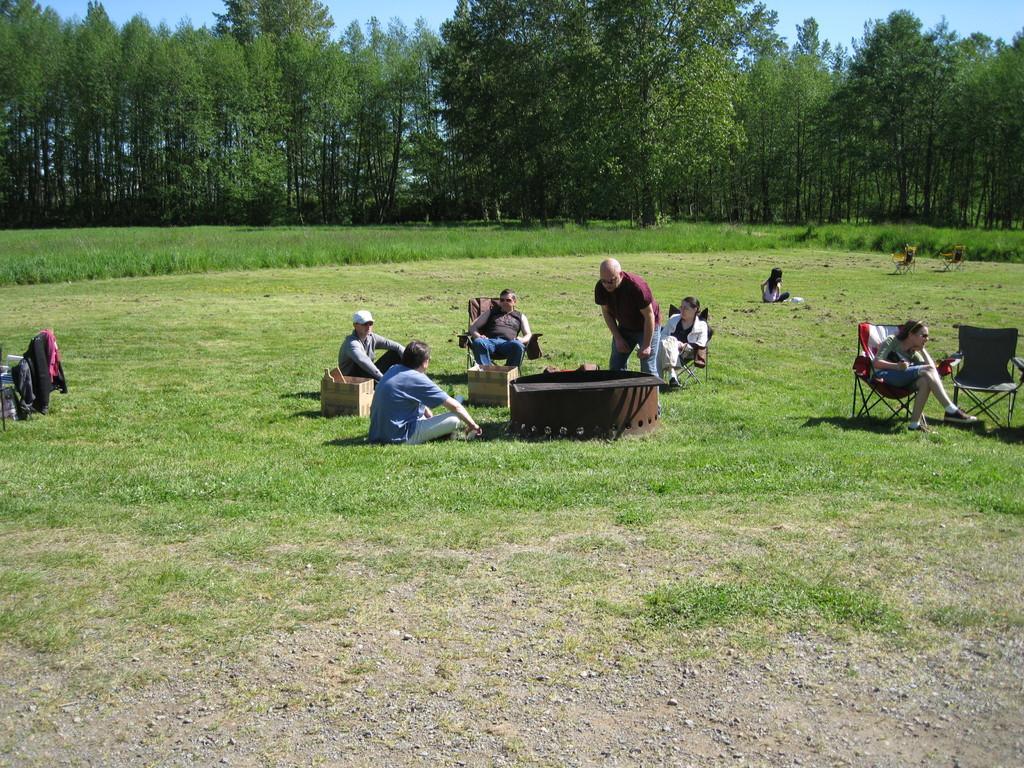Could you give a brief overview of what you see in this image? At the bottom of the image on the ground there is grass. And there are three persons sitting on the chairs. And there are few people sitting on the ground. There are few empty chairs. On the ground there are boxes and some other things. In the background there are trees. 